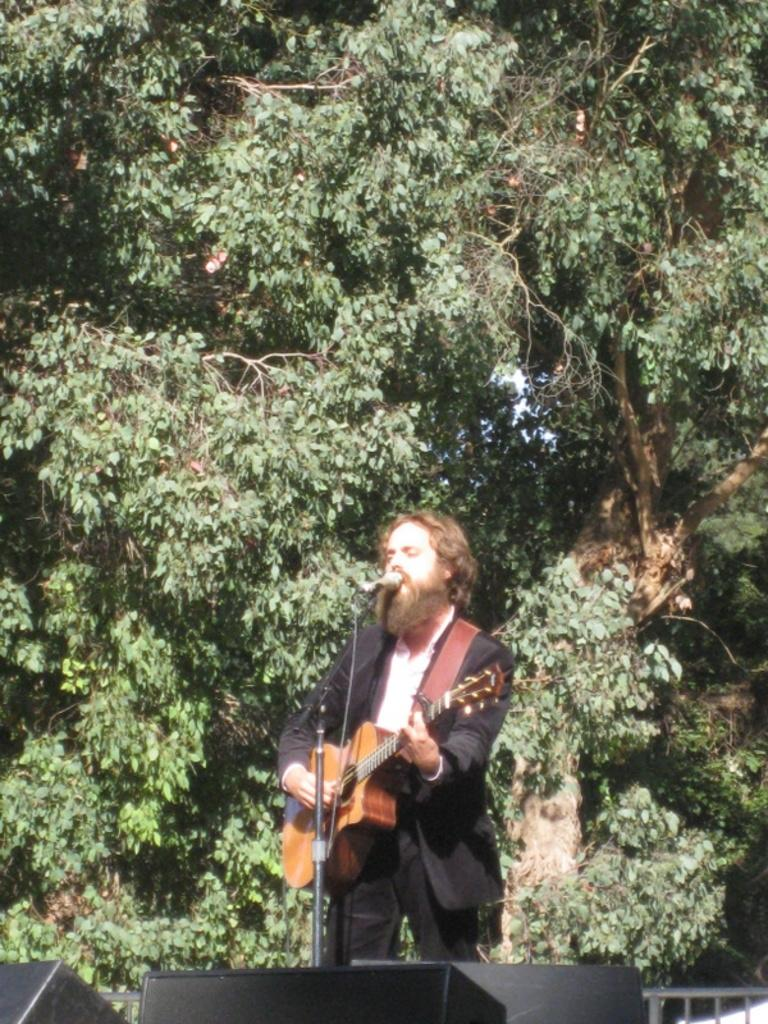Who is the main subject in the image? There is a man in the image. Where is the man located in the image? The man is standing on a stage. What is the man holding in the image? The man is holding a guitar. What is the man doing with the microphone in the image? The man is singing into a microphone. What can be seen in the background of the image? There is a big tree behind the man. How many frogs are sitting on the man's wrist in the image? There are no frogs present in the image, and the man's wrist is not visible. 